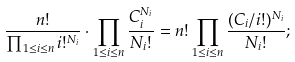Convert formula to latex. <formula><loc_0><loc_0><loc_500><loc_500>\frac { n ! } { \prod _ { 1 \leq i \leq n } i ! ^ { N _ { i } } } \cdot \prod _ { 1 \leq i \leq n } \frac { C _ { i } ^ { N _ { i } } } { N _ { i } ! } = n ! \prod _ { 1 \leq i \leq n } \frac { ( C _ { i } / i ! ) ^ { N _ { i } } } { N _ { i } ! } ;</formula> 